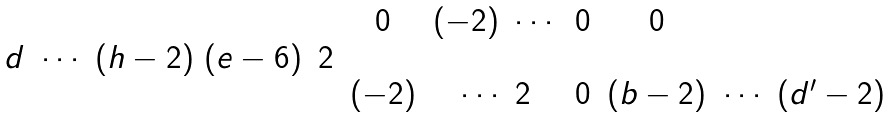<formula> <loc_0><loc_0><loc_500><loc_500>\begin{matrix} & & 0 & ( - 2 ) \ \cdots & 0 & 0 & \\ d \ \cdots \ ( h - 2 ) \ ( e - 6 ) & 2 & & & & & \\ & & ( - 2 ) & \cdots \ 2 & 0 & ( b - 2 ) & \cdots \ ( d ^ { \prime } - 2 ) \end{matrix}</formula> 